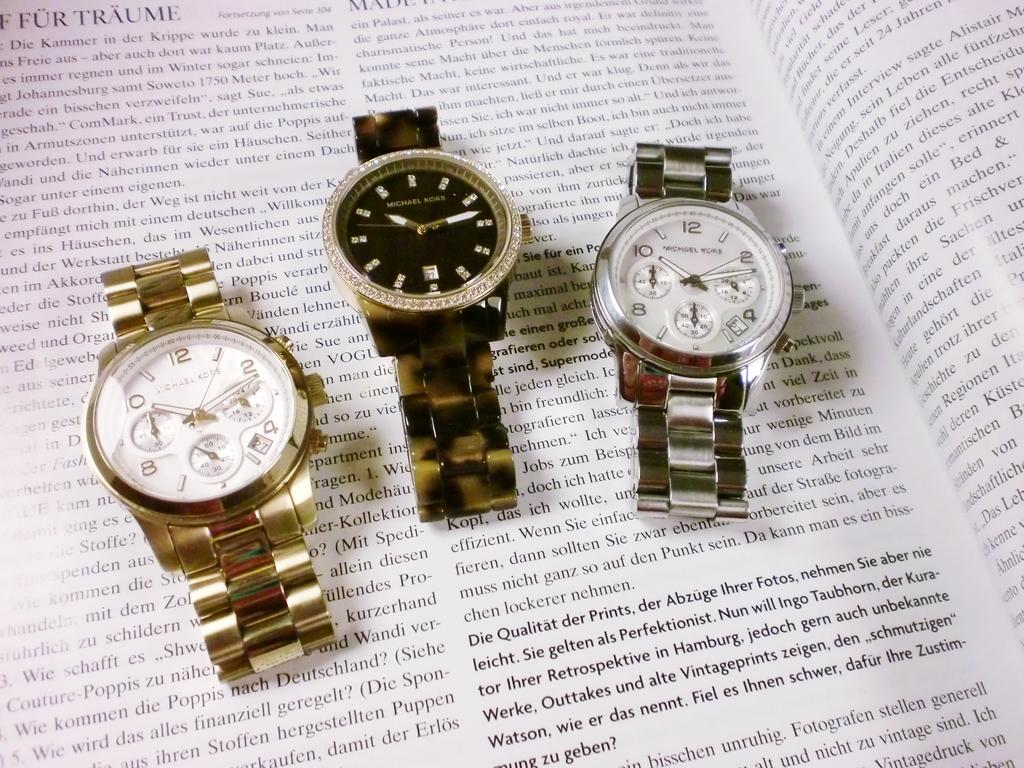Provide a one-sentence caption for the provided image. Three Michael Kors watches placed on top of a book. 